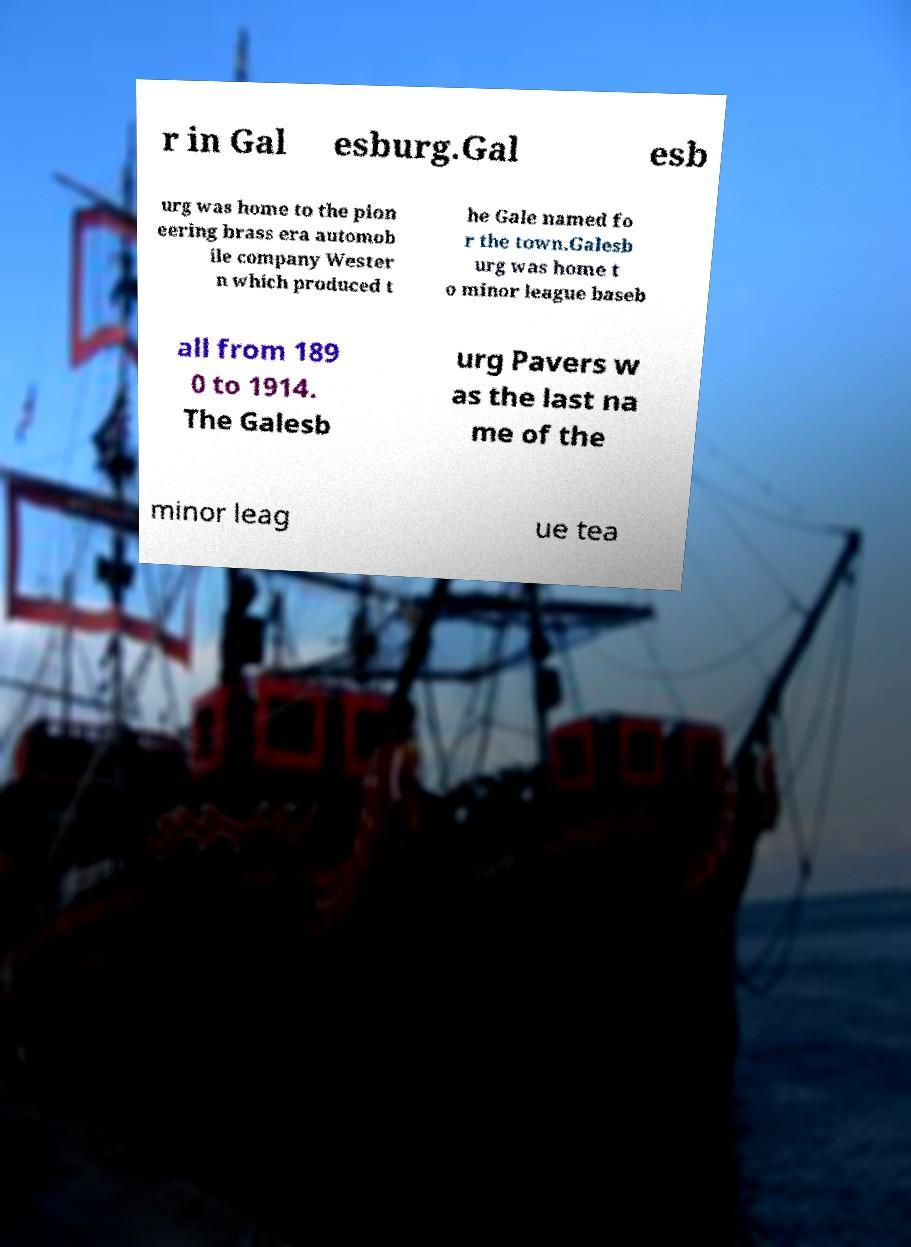What messages or text are displayed in this image? I need them in a readable, typed format. r in Gal esburg.Gal esb urg was home to the pion eering brass era automob ile company Wester n which produced t he Gale named fo r the town.Galesb urg was home t o minor league baseb all from 189 0 to 1914. The Galesb urg Pavers w as the last na me of the minor leag ue tea 